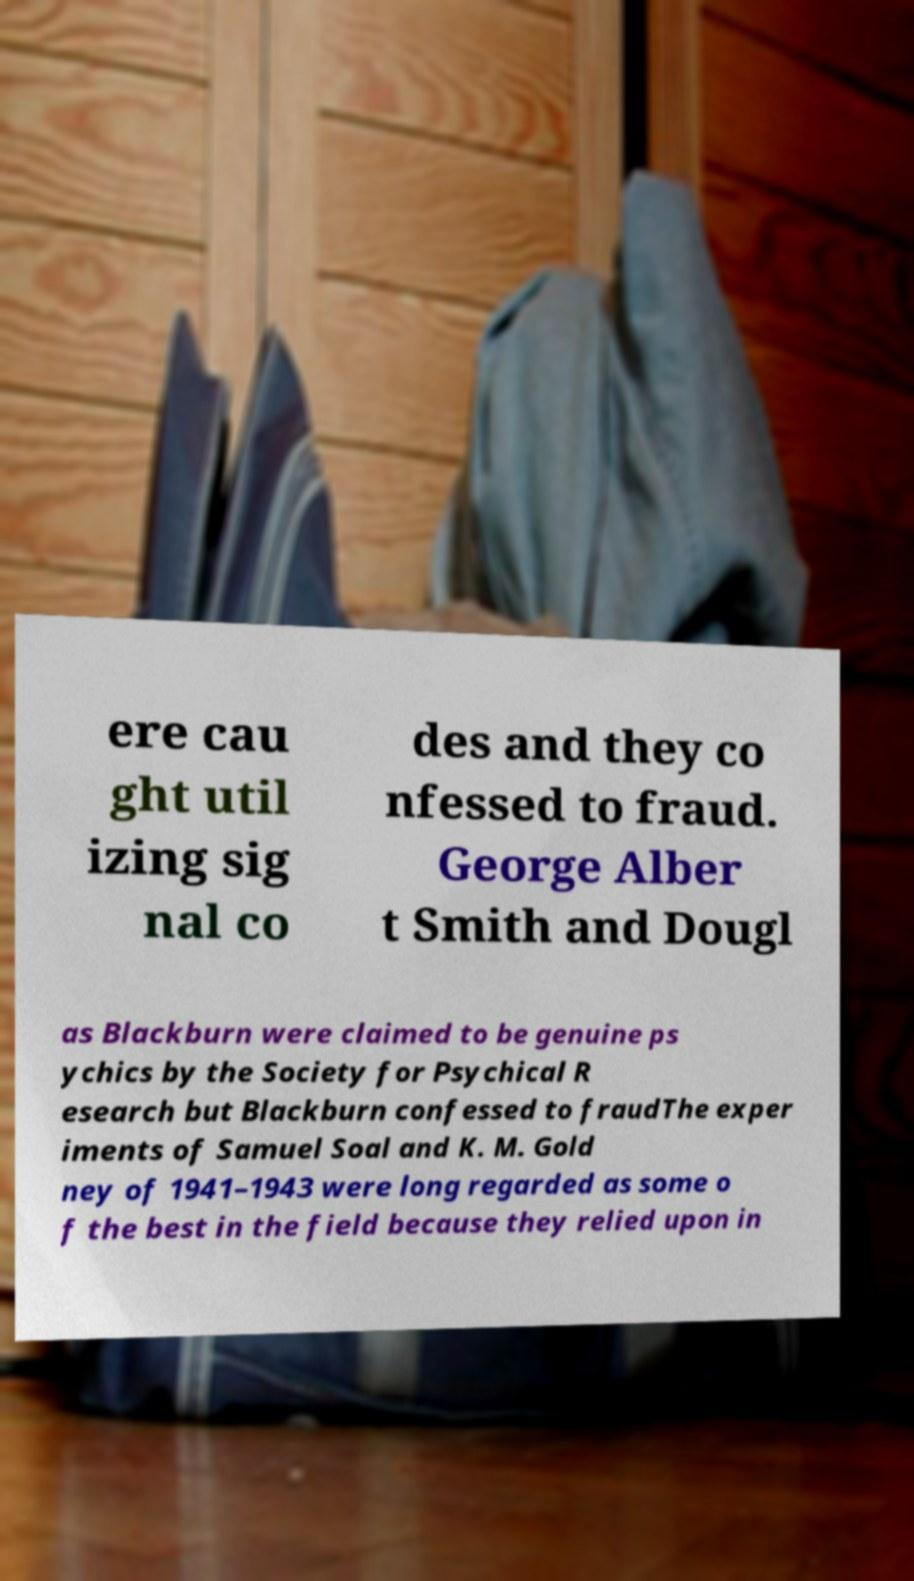There's text embedded in this image that I need extracted. Can you transcribe it verbatim? ere cau ght util izing sig nal co des and they co nfessed to fraud. George Alber t Smith and Dougl as Blackburn were claimed to be genuine ps ychics by the Society for Psychical R esearch but Blackburn confessed to fraudThe exper iments of Samuel Soal and K. M. Gold ney of 1941–1943 were long regarded as some o f the best in the field because they relied upon in 